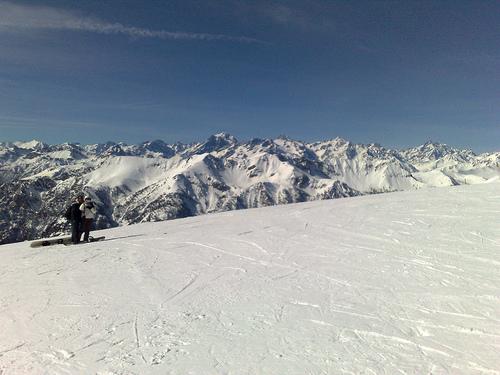What do people do on this slope?
Quick response, please. Ski. What is covering the floor?
Concise answer only. Snow. Is there snow?
Concise answer only. Yes. 